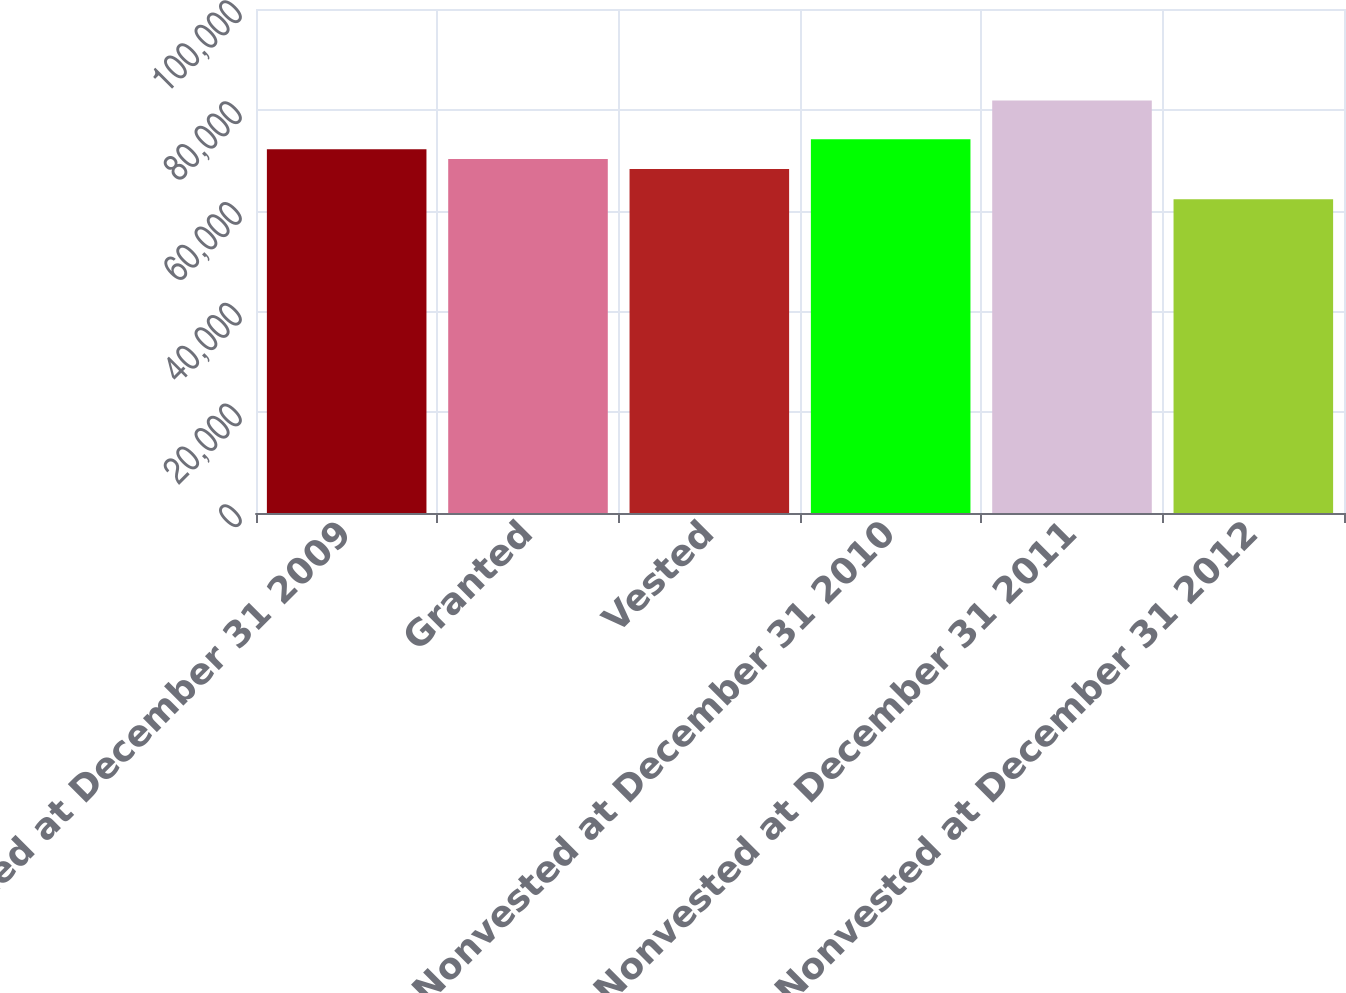Convert chart to OTSL. <chart><loc_0><loc_0><loc_500><loc_500><bar_chart><fcel>Nonvested at December 31 2009<fcel>Granted<fcel>Vested<fcel>Nonvested at December 31 2010<fcel>Nonvested at December 31 2011<fcel>Nonvested at December 31 2012<nl><fcel>72189.2<fcel>70227.6<fcel>68266<fcel>74150.8<fcel>81845<fcel>62229<nl></chart> 